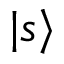<formula> <loc_0><loc_0><loc_500><loc_500>| s \rangle</formula> 